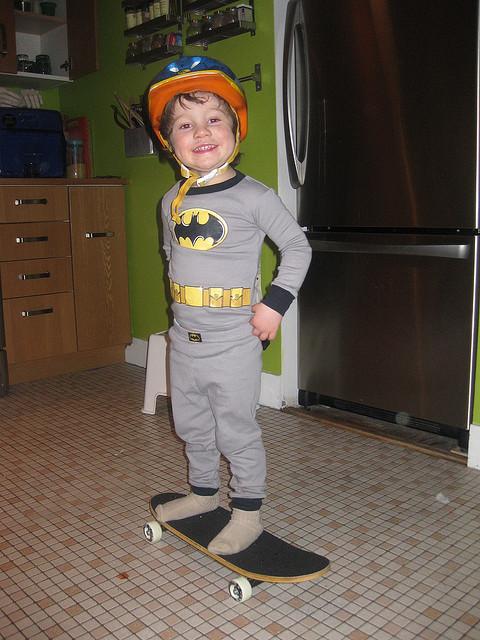Is this kid missing any teeth?
Concise answer only. No. What superhero does he like?
Concise answer only. Batman. Is the boy happy?
Give a very brief answer. Yes. How many kids are in the room?
Write a very short answer. 1. What do you call the little boy's footwear?
Write a very short answer. Socks. Is he wearing appropriate safety gear?
Answer briefly. No. What is he on?
Write a very short answer. Skateboard. What is this person dressed up as?
Write a very short answer. Batman. What is the floor made of?
Quick response, please. Tile. 